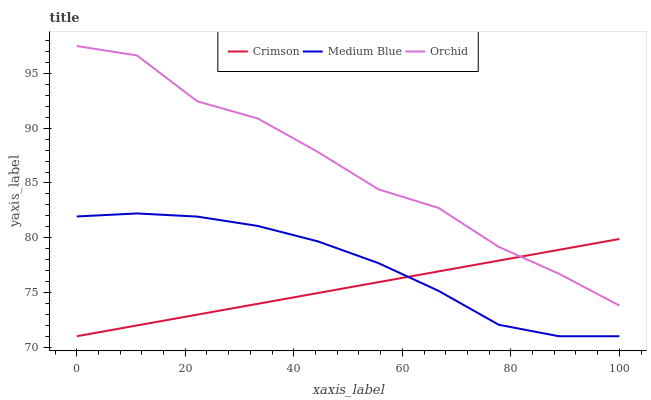Does Crimson have the minimum area under the curve?
Answer yes or no. Yes. Does Orchid have the maximum area under the curve?
Answer yes or no. Yes. Does Medium Blue have the minimum area under the curve?
Answer yes or no. No. Does Medium Blue have the maximum area under the curve?
Answer yes or no. No. Is Crimson the smoothest?
Answer yes or no. Yes. Is Orchid the roughest?
Answer yes or no. Yes. Is Medium Blue the smoothest?
Answer yes or no. No. Is Medium Blue the roughest?
Answer yes or no. No. Does Crimson have the lowest value?
Answer yes or no. Yes. Does Orchid have the lowest value?
Answer yes or no. No. Does Orchid have the highest value?
Answer yes or no. Yes. Does Medium Blue have the highest value?
Answer yes or no. No. Is Medium Blue less than Orchid?
Answer yes or no. Yes. Is Orchid greater than Medium Blue?
Answer yes or no. Yes. Does Medium Blue intersect Crimson?
Answer yes or no. Yes. Is Medium Blue less than Crimson?
Answer yes or no. No. Is Medium Blue greater than Crimson?
Answer yes or no. No. Does Medium Blue intersect Orchid?
Answer yes or no. No. 